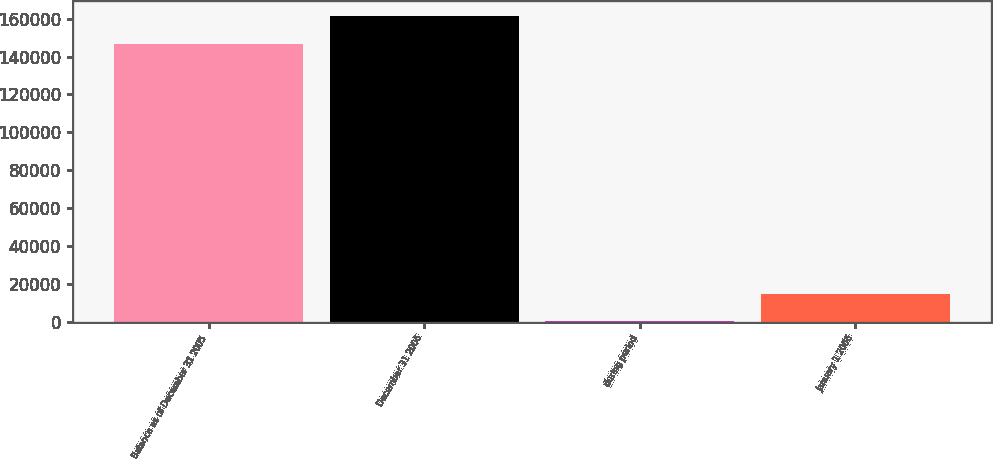Convert chart. <chart><loc_0><loc_0><loc_500><loc_500><bar_chart><fcel>Balance as of December 31 2005<fcel>December 31 2006<fcel>during period<fcel>January 1 2006<nl><fcel>146700<fcel>161324<fcel>457<fcel>15081.3<nl></chart> 